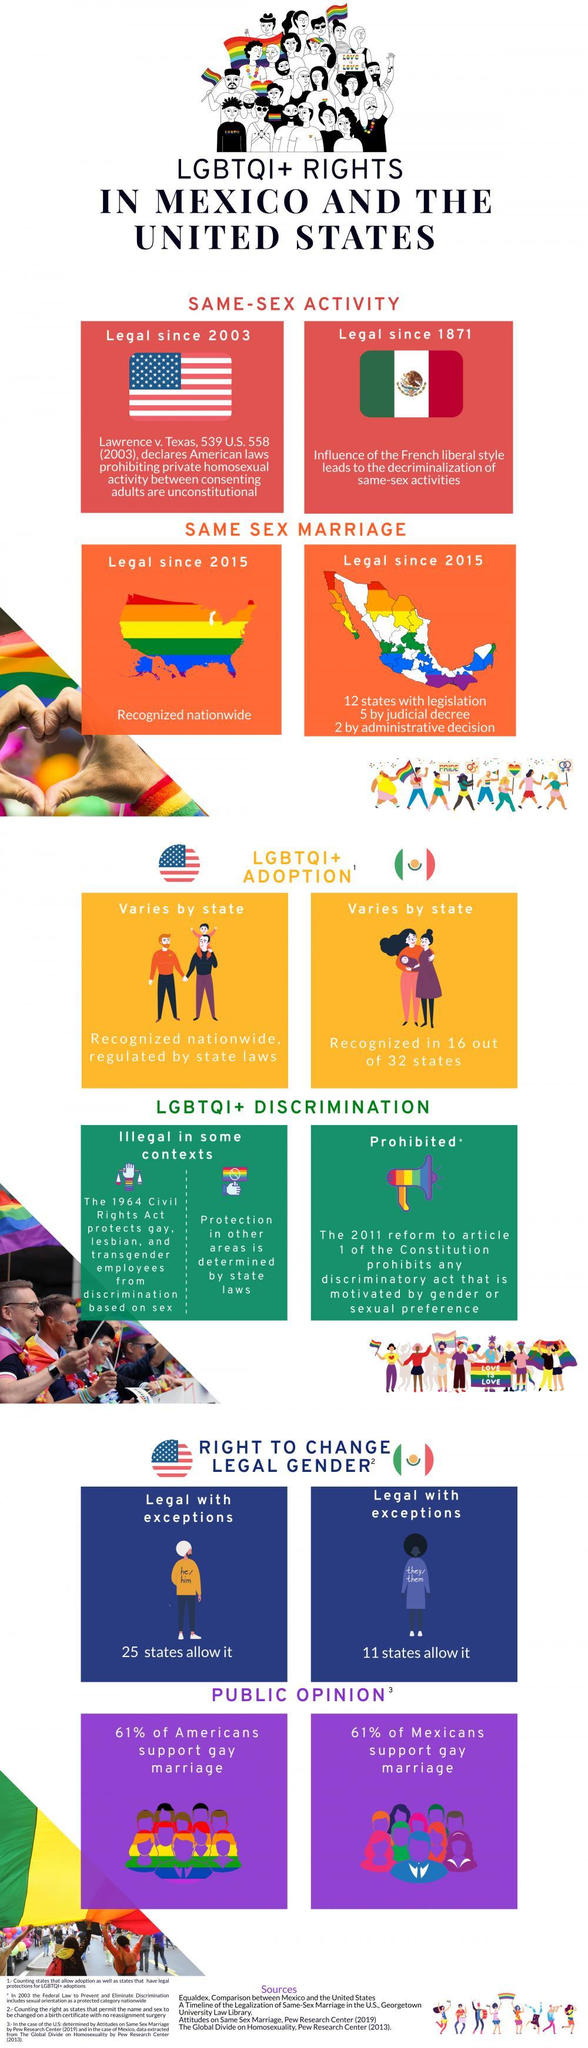In which country does 16 out of 32 states recognize LGBTQI+ adoption?
Answer the question with a short phrase. Mexico How many states in the US allow change in gender? 25 